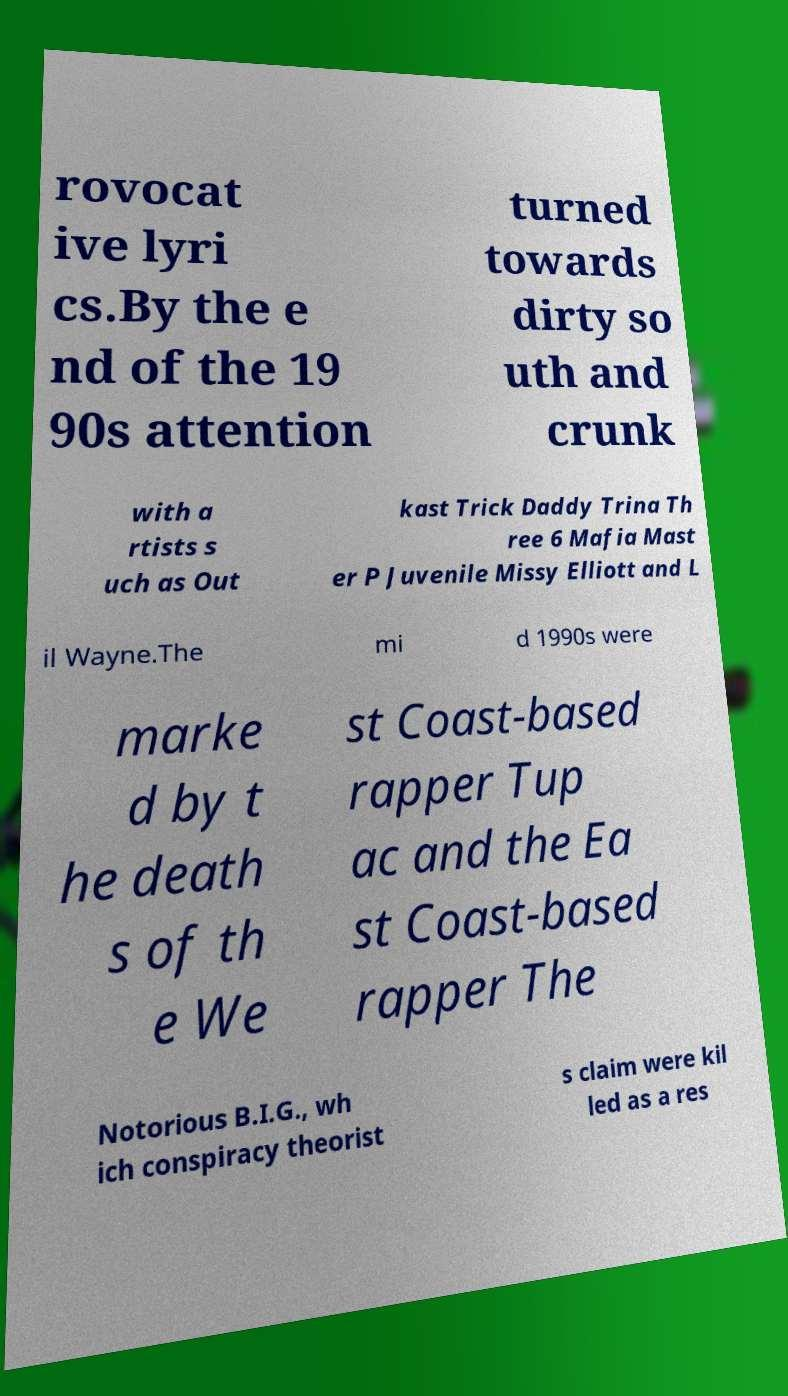I need the written content from this picture converted into text. Can you do that? rovocat ive lyri cs.By the e nd of the 19 90s attention turned towards dirty so uth and crunk with a rtists s uch as Out kast Trick Daddy Trina Th ree 6 Mafia Mast er P Juvenile Missy Elliott and L il Wayne.The mi d 1990s were marke d by t he death s of th e We st Coast-based rapper Tup ac and the Ea st Coast-based rapper The Notorious B.I.G., wh ich conspiracy theorist s claim were kil led as a res 